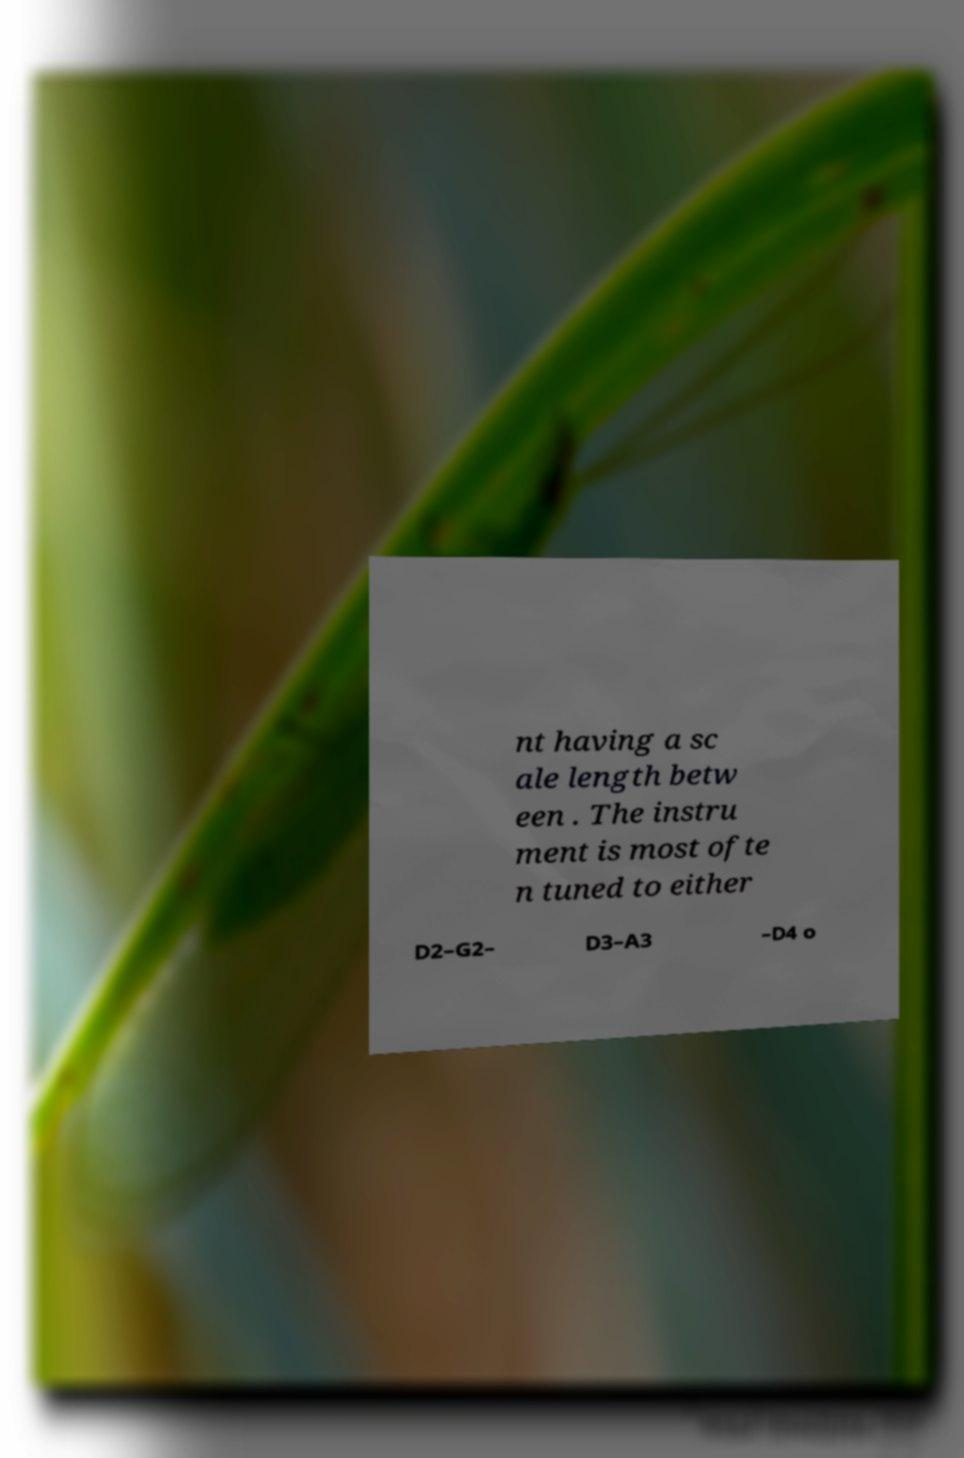I need the written content from this picture converted into text. Can you do that? nt having a sc ale length betw een . The instru ment is most ofte n tuned to either D2–G2– D3–A3 –D4 o 